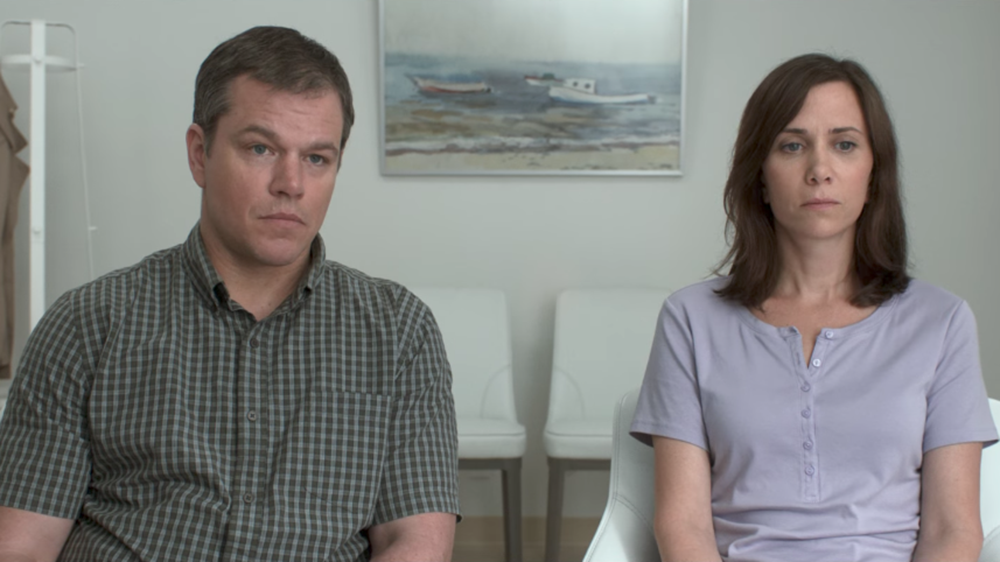Can you describe the emotions portrayed by the individuals in this image? The individuals in the image appear to be reflecting on something serious or somber. Their neutral expressions suggest a sense of introspection or contemplation. The setting, with its minimalist design and the calm depiction of a boat on the wall, further emphasizes the subdued atmosphere. Both individuals seem to be deep in thought, contributing to an overall sense of quiet and focus. Do you think there's a specific reason for their expressions? It's likely that the individuals' expressions are shaped by a significant event or conversation. The earnest and calm demeanor could indicate they are waiting for something important, perhaps a serious discussion or revelation. The setting suggests a controlled and reflective environment, which might hint at a poignant or personal moment being captured. What kind of room do you think this is? The room appears to be designed with a minimalist and functional aesthetic. Given the sparse furnishings and the neutral tones, it could be a waiting room, an office, or even a consultation space. The painting of the boat on the wall and the chairs aligned in the background indicate that it is a place intended for calm and contemplation, possibly used for quiet discussions or professional consultations. Let's get creative! Imagine this scene is part of a futuristic movie where people can shrink themselves. How does this image fit into that story? In a futuristic world where people can shrink themselves to solve overpopulation and ecological crises, this image could depict a pivotal moment of decision. The individuals might be part of a program that offers this drastic solution, sitting in a pre-procedure consultation room. Their somber expressions reveal the gravity of the choice they are about to make, understanding that shrinking themselves will have irreversible consequences on their lives. The stark room and the painting of the boat could symbolize the journey they are about to embark upon—a journey that drastically reduces their physical size but significantly impacts the world. 